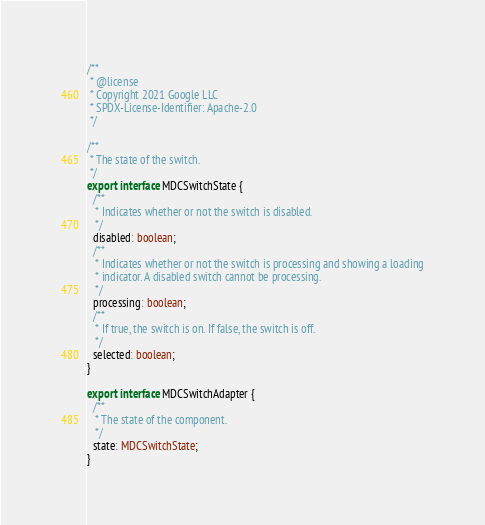Convert code to text. <code><loc_0><loc_0><loc_500><loc_500><_TypeScript_>/**
 * @license
 * Copyright 2021 Google LLC
 * SPDX-License-Identifier: Apache-2.0
 */

/**
 * The state of the switch.
 */
export interface MDCSwitchState {
  /**
   * Indicates whether or not the switch is disabled.
   */
  disabled: boolean;
  /**
   * Indicates whether or not the switch is processing and showing a loading
   * indicator. A disabled switch cannot be processing.
   */
  processing: boolean;
  /**
   * If true, the switch is on. If false, the switch is off.
   */
  selected: boolean;
}

export interface MDCSwitchAdapter {
  /**
   * The state of the component.
   */
  state: MDCSwitchState;
}
</code> 